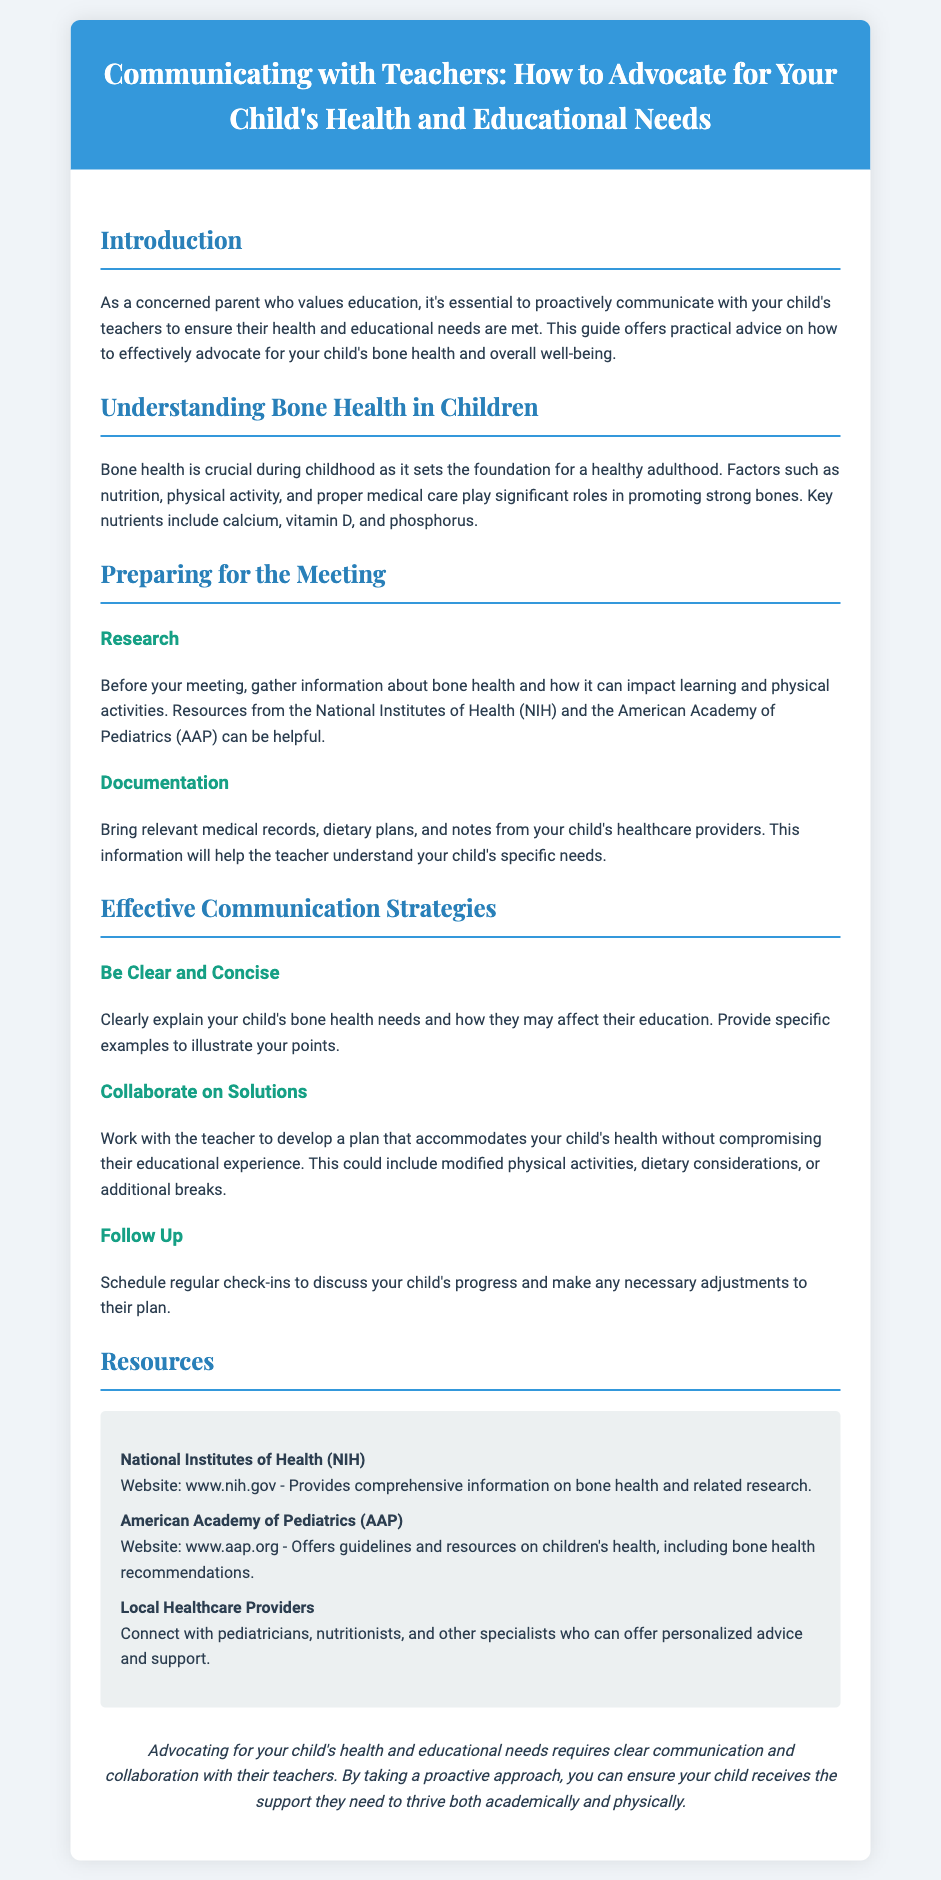What is the primary focus of this document? The primary focus is on communicating with teachers about a child's health and educational needs.
Answer: Communicating with teachers What nutrients are mentioned as important for bone health? The document lists calcium, vitamin D, and phosphorus as key nutrients for bone health.
Answer: Calcium, vitamin D, phosphorus Which organizations are referenced as resources? Resources from the National Institutes of Health and the American Academy of Pediatrics are mentioned.
Answer: National Institutes of Health, American Academy of Pediatrics What is suggested to bring to a meeting with a teacher? The document advises bringing relevant medical records, dietary plans, and notes from healthcare providers.
Answer: Medical records, dietary plans, notes What is the purpose of regular check-ins? Regular check-ins are suggested to discuss the child's progress and make adjustments to their plan as needed.
Answer: Discuss progress How should parents communicate their child's needs? Parents are encouraged to be clear and concise when explaining their child's bone health needs.
Answer: Clear and concise What is one strategy for developing solutions with the teacher? Collaborating on a plan that accommodates the child's health while ensuring they receive an education is recommended.
Answer: Collaborate on a plan What is the significance of bone health in childhood? Bone health is crucial as it sets the foundation for a healthy adulthood.
Answer: Foundation for a healthy adulthood Where can parents find more information on bone health? The National Institutes of Health website is mentioned as a source of comprehensive information on bone health.
Answer: National Institutes of Health website 